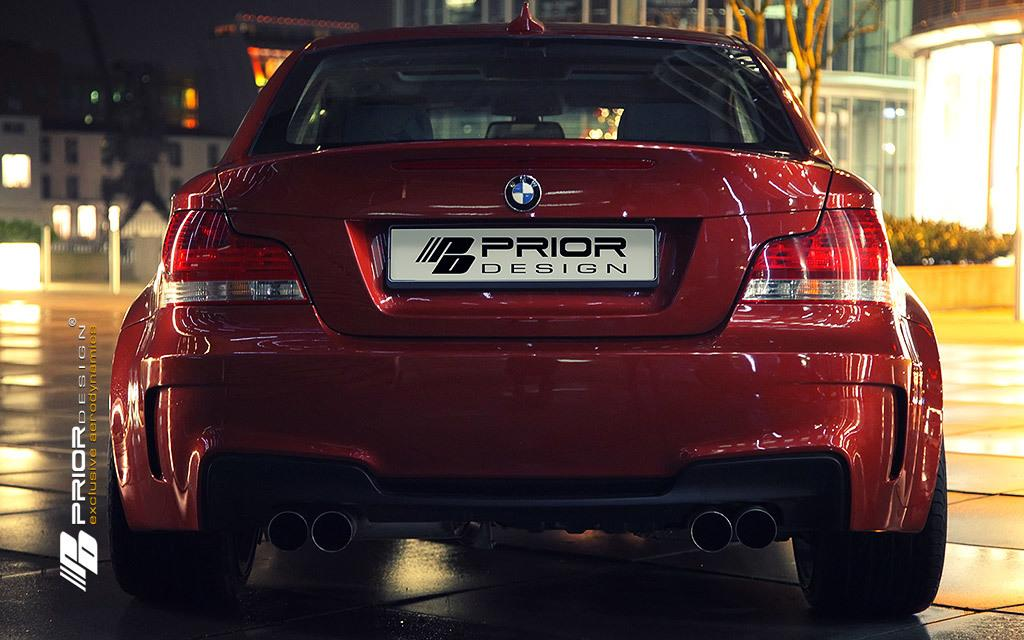What color is the car in the image? The car in the image is red. What can be seen in the background of the image? Buildings, trees, and windows are visible in the background of the image. How does the car help the trees in the image? The car does not help the trees in the image; it is a separate object and has no direct interaction with the trees. 